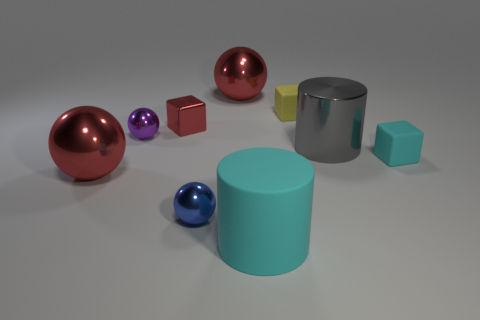What number of small balls are there?
Your answer should be compact. 2. How many objects are big cyan metal cylinders or spheres behind the small blue object?
Offer a terse response. 3. Does the matte block in front of the shiny block have the same size as the blue shiny thing?
Keep it short and to the point. Yes. How many metallic objects are yellow blocks or cyan blocks?
Your response must be concise. 0. How big is the block that is in front of the purple sphere?
Ensure brevity in your answer.  Small. Does the tiny blue thing have the same shape as the tiny purple thing?
Provide a succinct answer. Yes. What number of small things are blue metal spheres or cyan metal cylinders?
Give a very brief answer. 1. Are there any big red shiny things in front of the red block?
Your answer should be compact. Yes. Is the number of big cyan objects to the right of the yellow object the same as the number of purple metal blocks?
Your response must be concise. Yes. There is another metal object that is the same shape as the small cyan object; what size is it?
Offer a terse response. Small. 